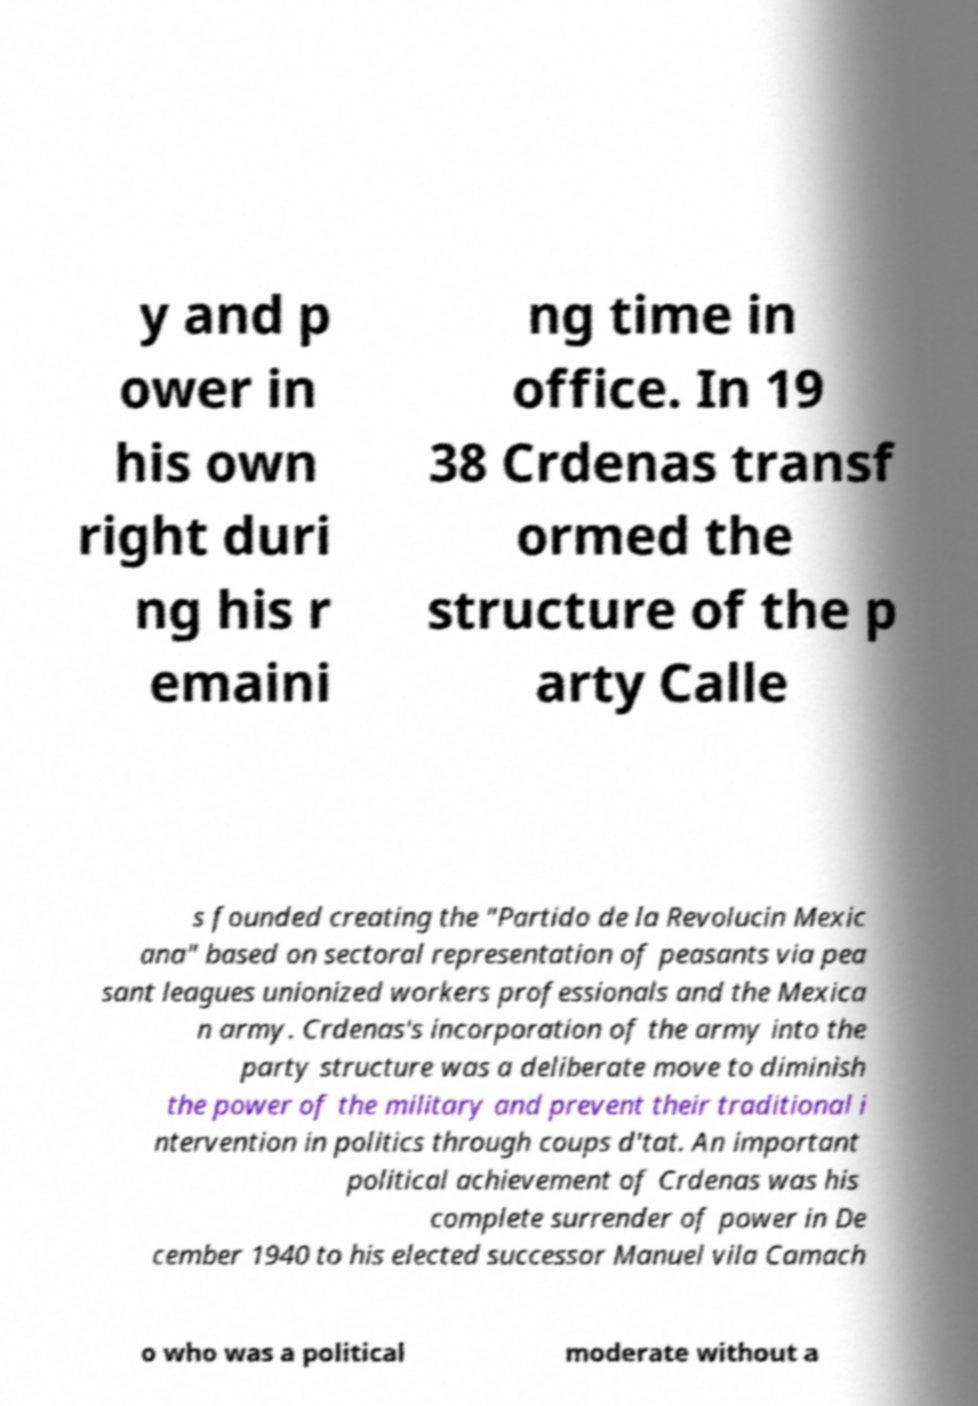For documentation purposes, I need the text within this image transcribed. Could you provide that? y and p ower in his own right duri ng his r emaini ng time in office. In 19 38 Crdenas transf ormed the structure of the p arty Calle s founded creating the "Partido de la Revolucin Mexic ana" based on sectoral representation of peasants via pea sant leagues unionized workers professionals and the Mexica n army. Crdenas's incorporation of the army into the party structure was a deliberate move to diminish the power of the military and prevent their traditional i ntervention in politics through coups d'tat. An important political achievement of Crdenas was his complete surrender of power in De cember 1940 to his elected successor Manuel vila Camach o who was a political moderate without a 